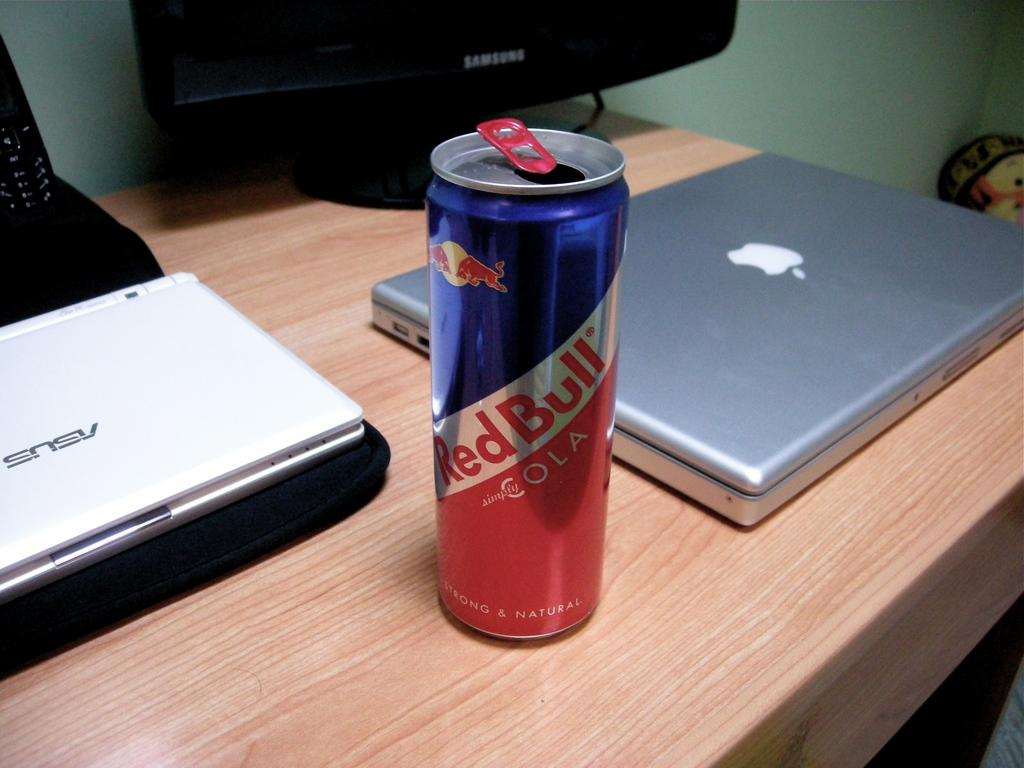Provide a one-sentence caption for the provided image. A can of Red Bull on top of a desk with a Mac computer next to it. 